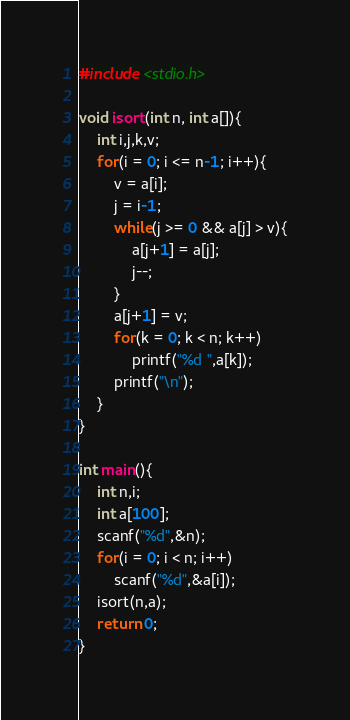Convert code to text. <code><loc_0><loc_0><loc_500><loc_500><_C_>#include <stdio.h>

void isort(int n, int a[]){
	int i,j,k,v;
	for(i = 0; i <= n-1; i++){
		v = a[i];
		j = i-1;
		while(j >= 0 && a[j] > v){
			a[j+1] = a[j];
			j--;
		}
		a[j+1] = v;
		for(k = 0; k < n; k++)
			printf("%d ",a[k]);
		printf("\n");
	}
}

int main(){
	int n,i;
	int a[100];
	scanf("%d",&n);
	for(i = 0; i < n; i++)
		scanf("%d",&a[i]);
	isort(n,a);
	return 0;
}</code> 